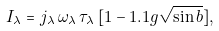Convert formula to latex. <formula><loc_0><loc_0><loc_500><loc_500>I _ { \lambda } = j _ { \lambda } \, \omega _ { \lambda } \, \tau _ { \lambda } \, [ 1 - 1 . 1 g \sqrt { \sin b } ] ,</formula> 